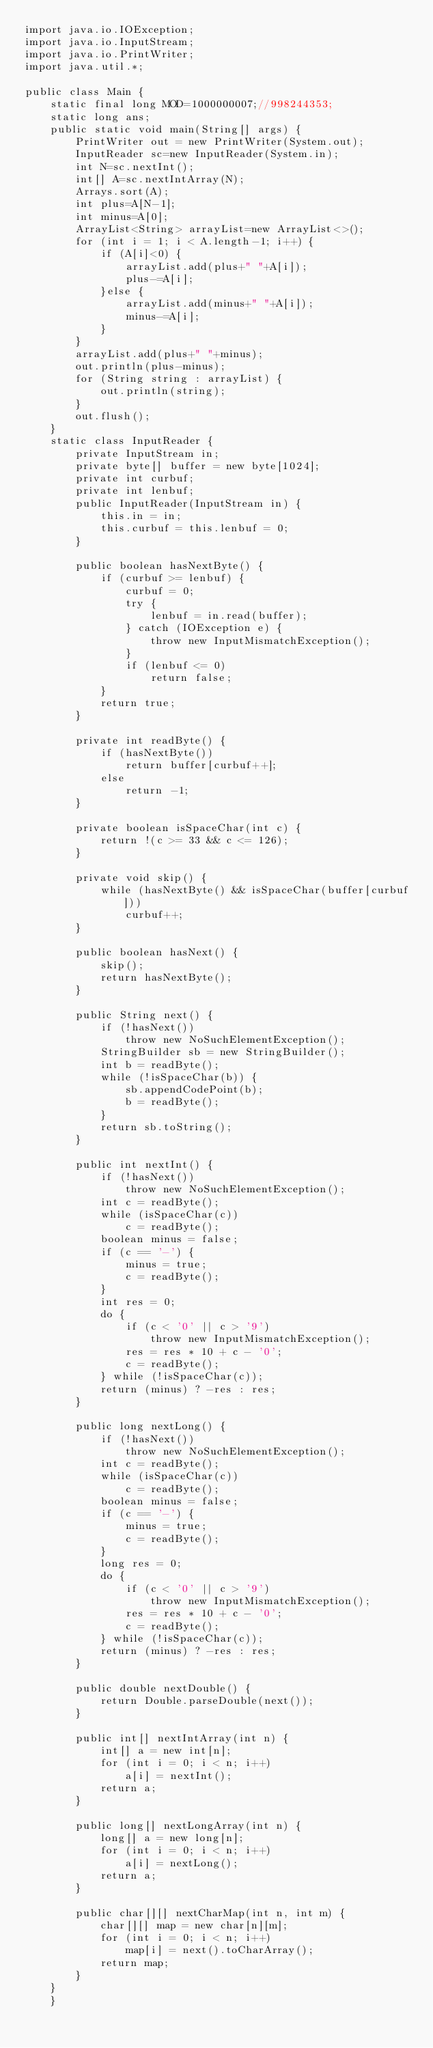Convert code to text. <code><loc_0><loc_0><loc_500><loc_500><_Java_>import java.io.IOException;
import java.io.InputStream;
import java.io.PrintWriter;
import java.util.*;

public class Main {
	static final long MOD=1000000007;//998244353;
	static long ans;
	public static void main(String[] args) {
		PrintWriter out = new PrintWriter(System.out);
		InputReader sc=new InputReader(System.in);
		int N=sc.nextInt();
		int[] A=sc.nextIntArray(N);
		Arrays.sort(A);
		int plus=A[N-1];
		int minus=A[0];
		ArrayList<String> arrayList=new ArrayList<>();
		for (int i = 1; i < A.length-1; i++) {
			if (A[i]<0) {
				arrayList.add(plus+" "+A[i]);
				plus-=A[i];
			}else {
				arrayList.add(minus+" "+A[i]);
				minus-=A[i];
			}
		}
		arrayList.add(plus+" "+minus);
		out.println(plus-minus);
		for (String string : arrayList) {
			out.println(string);
		}
		out.flush();
 	}
	static class InputReader { 
		private InputStream in;
		private byte[] buffer = new byte[1024];
		private int curbuf;
		private int lenbuf;
		public InputReader(InputStream in) {
			this.in = in;
			this.curbuf = this.lenbuf = 0;
		}
 
		public boolean hasNextByte() {
			if (curbuf >= lenbuf) {
				curbuf = 0;
				try {
					lenbuf = in.read(buffer);
				} catch (IOException e) {
					throw new InputMismatchException();
				}
				if (lenbuf <= 0)
					return false;
			}
			return true;
		}
 
		private int readByte() {
			if (hasNextByte())
				return buffer[curbuf++];
			else
				return -1;
		}
 
		private boolean isSpaceChar(int c) {
			return !(c >= 33 && c <= 126);
		}
 
		private void skip() {
			while (hasNextByte() && isSpaceChar(buffer[curbuf]))
				curbuf++;
		}
 
		public boolean hasNext() {
			skip();
			return hasNextByte();
		}
 
		public String next() {
			if (!hasNext())
				throw new NoSuchElementException();
			StringBuilder sb = new StringBuilder();
			int b = readByte();
			while (!isSpaceChar(b)) {
				sb.appendCodePoint(b);
				b = readByte();
			}
			return sb.toString();
		}
 
		public int nextInt() {
			if (!hasNext())
				throw new NoSuchElementException();
			int c = readByte();
			while (isSpaceChar(c))
				c = readByte();
			boolean minus = false;
			if (c == '-') {
				minus = true;
				c = readByte();
			}
			int res = 0;
			do {
				if (c < '0' || c > '9')
					throw new InputMismatchException();
				res = res * 10 + c - '0';
				c = readByte();
			} while (!isSpaceChar(c));
			return (minus) ? -res : res;
		}
 
		public long nextLong() {
			if (!hasNext())
				throw new NoSuchElementException();
			int c = readByte();
			while (isSpaceChar(c))
				c = readByte();
			boolean minus = false;
			if (c == '-') {
				minus = true;
				c = readByte();
			}
			long res = 0;
			do {
				if (c < '0' || c > '9')
					throw new InputMismatchException();
				res = res * 10 + c - '0';
				c = readByte();
			} while (!isSpaceChar(c));
			return (minus) ? -res : res;
		}
 
		public double nextDouble() {
			return Double.parseDouble(next());
		}
 
		public int[] nextIntArray(int n) {
			int[] a = new int[n];
			for (int i = 0; i < n; i++)
				a[i] = nextInt();
			return a;
		}
 
		public long[] nextLongArray(int n) {
			long[] a = new long[n];
			for (int i = 0; i < n; i++)
				a[i] = nextLong();
			return a;
		}
 
		public char[][] nextCharMap(int n, int m) {
			char[][] map = new char[n][m];
			for (int i = 0; i < n; i++)
				map[i] = next().toCharArray();
			return map;
		}
	}
	}
</code> 